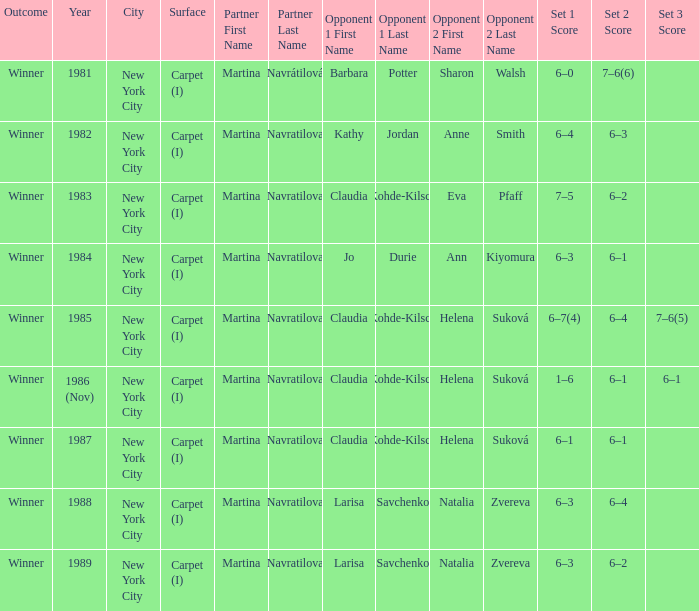What was the outcome for the match in 1989? Winner. Parse the full table. {'header': ['Outcome', 'Year', 'City', 'Surface', 'Partner First Name', 'Partner Last Name', 'Opponent 1 First Name', 'Opponent 1 Last Name', 'Opponent 2 First Name', 'Opponent 2 Last Name', 'Set 1 Score', 'Set 2 Score', 'Set 3 Score'], 'rows': [['Winner', '1981', 'New York City', 'Carpet (I)', 'Martina', 'Navrátilová', 'Barbara', 'Potter', 'Sharon', 'Walsh', '6–0', '7–6(6)', ''], ['Winner', '1982', 'New York City', 'Carpet (I)', 'Martina', 'Navratilova', 'Kathy', 'Jordan', 'Anne', 'Smith', '6–4', '6–3', ''], ['Winner', '1983', 'New York City', 'Carpet (I)', 'Martina', 'Navratilova', 'Claudia', 'Kohde-Kilsch', 'Eva', 'Pfaff', '7–5', '6–2', ''], ['Winner', '1984', 'New York City', 'Carpet (I)', 'Martina', 'Navratilova', 'Jo', 'Durie', 'Ann', 'Kiyomura', '6–3', '6–1', ''], ['Winner', '1985', 'New York City', 'Carpet (I)', 'Martina', 'Navratilova', 'Claudia', 'Kohde-Kilsch', 'Helena', 'Suková', '6–7(4)', '6–4', '7–6(5)'], ['Winner', '1986 (Nov)', 'New York City', 'Carpet (I)', 'Martina', 'Navratilova', 'Claudia', 'Kohde-Kilsch', 'Helena', 'Suková', '1–6', '6–1', '6–1'], ['Winner', '1987', 'New York City', 'Carpet (I)', 'Martina', 'Navratilova', 'Claudia', 'Kohde-Kilsch', 'Helena', 'Suková', '6–1', '6–1', ''], ['Winner', '1988', 'New York City', 'Carpet (I)', 'Martina', 'Navratilova', 'Larisa', 'Savchenko', 'Natalia', 'Zvereva', '6–3', '6–4', ''], ['Winner', '1989', 'New York City', 'Carpet (I)', 'Martina', 'Navratilova', 'Larisa', 'Savchenko', 'Natalia', 'Zvereva', '6–3', '6–2', '']]} 